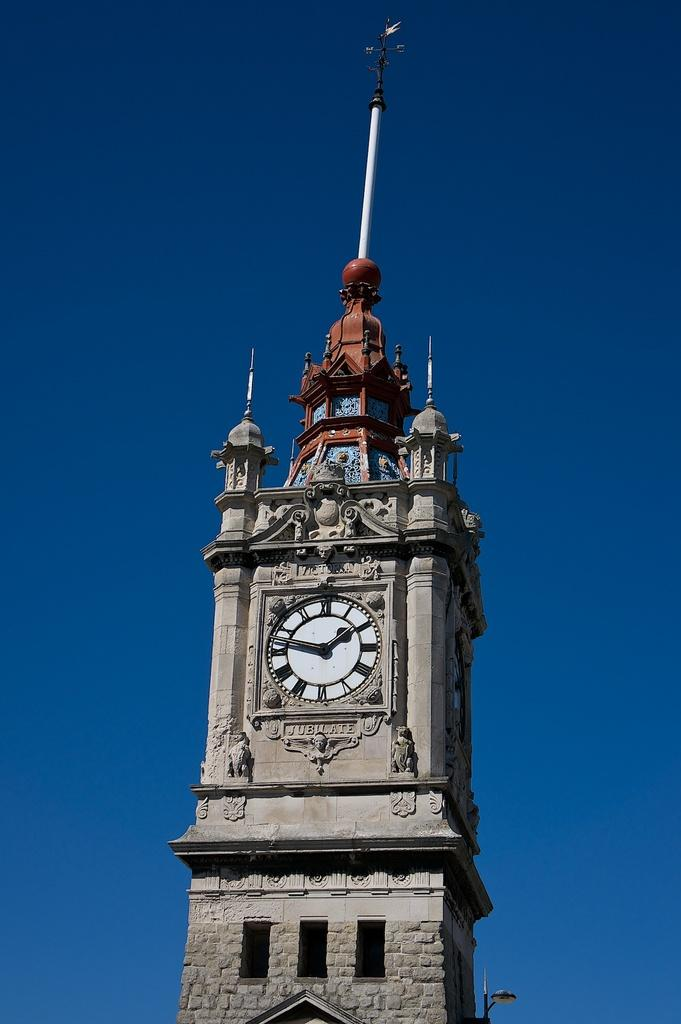What is the main structure in the image? There is a clock tower in the image. What can be seen in the background of the image? The sky is visible in the image. Can you determine the time of day based on the image? The image is likely taken during the day, as the sky appears bright. What type of judge is depicted in the image? There is no judge present in the image; it features a clock tower and the sky. How many passengers are visible in the image? There are no passengers present in the image. 